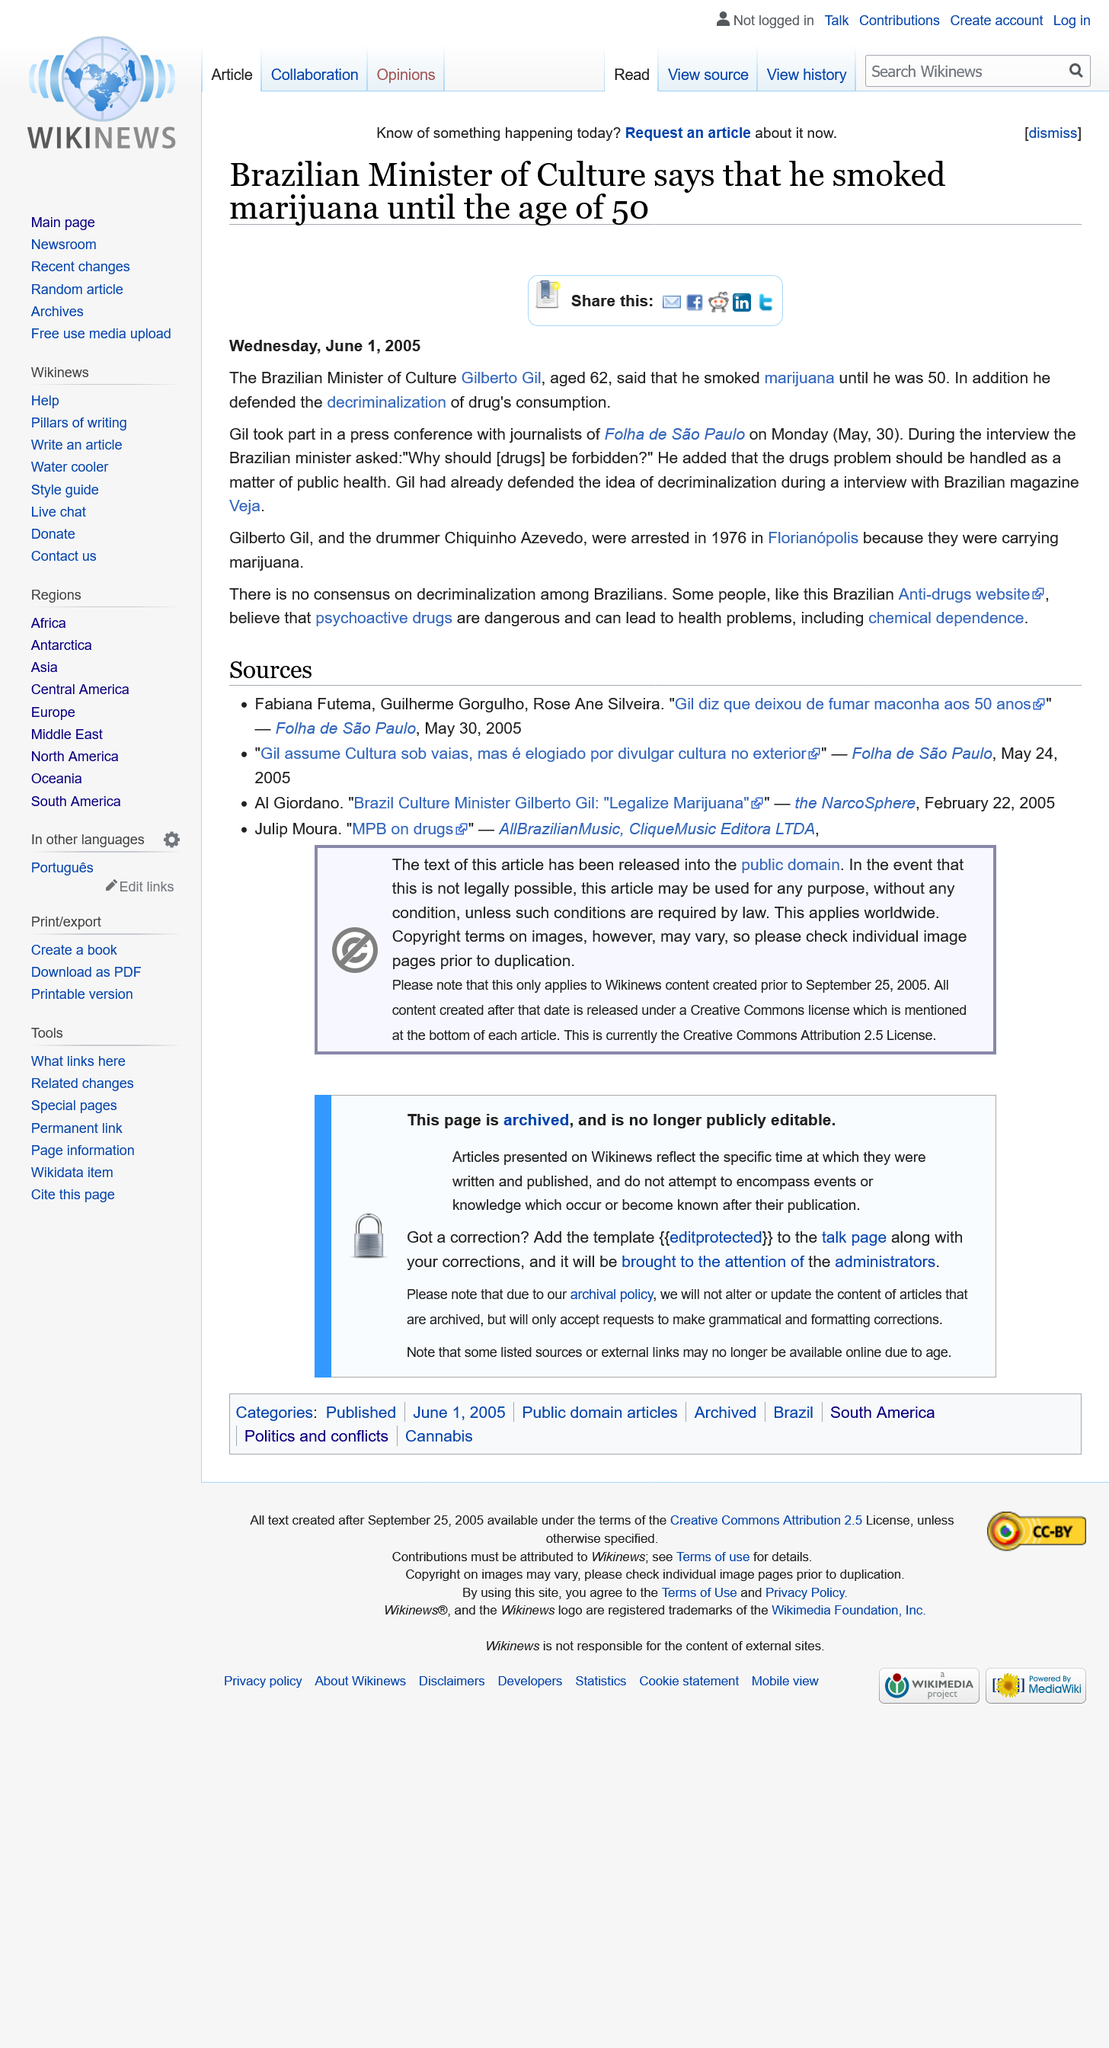Highlight a few significant elements in this photo. Gilberto Gil is the current Minister of Culture in Brazil. On May 30th 2005, the Brazilian Minister of Culture took part in a press conference. The Brazilian Minister of Culture has stated that he smoked marijuana until the age of 50. 